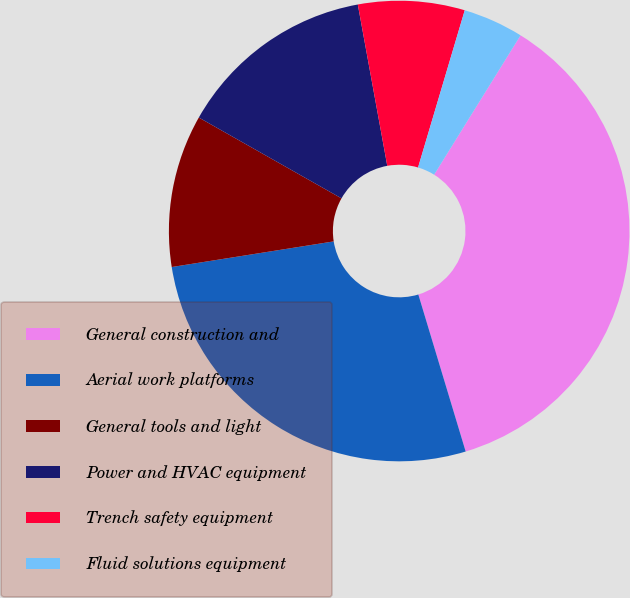Convert chart. <chart><loc_0><loc_0><loc_500><loc_500><pie_chart><fcel>General construction and<fcel>Aerial work platforms<fcel>General tools and light<fcel>Power and HVAC equipment<fcel>Trench safety equipment<fcel>Fluid solutions equipment<nl><fcel>36.5%<fcel>27.16%<fcel>10.7%<fcel>13.92%<fcel>7.47%<fcel>4.24%<nl></chart> 